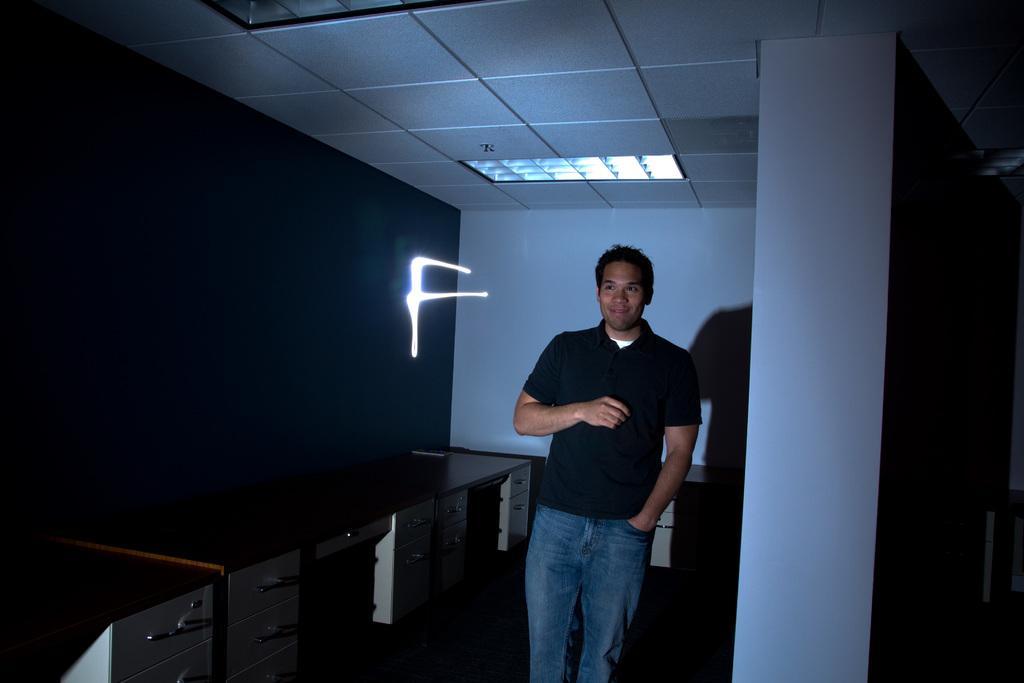Could you give a brief overview of what you see in this image? In the middle a man is standing, he wore a black color t-shirt and a jeans trouser. In the left side there is a light. 